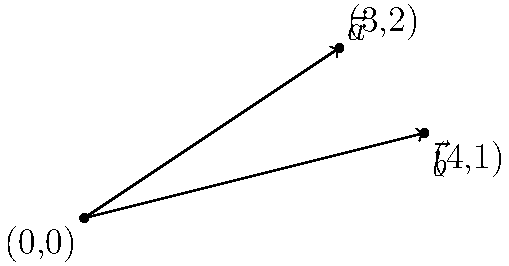Given two vectors $\vec{a} = (3,2)$ and $\vec{b} = (4,1)$ represented as arrows in a 2D plane, calculate their dot product. How would you approach this using your knowledge of vector operations and shell scripting? To calculate the dot product of two vectors $\vec{a} = (a_1, a_2)$ and $\vec{b} = (b_1, b_2)$ in a 2D plane, we use the formula:

$$\vec{a} \cdot \vec{b} = a_1b_1 + a_2b_2$$

For the given vectors $\vec{a} = (3,2)$ and $\vec{b} = (4,1)$:

1. Identify the components:
   $a_1 = 3$, $a_2 = 2$
   $b_1 = 4$, $b_2 = 1$

2. Multiply corresponding components:
   $a_1b_1 = 3 \times 4 = 12$
   $a_2b_2 = 2 \times 1 = 2$

3. Sum the products:
   $\vec{a} \cdot \vec{b} = 12 + 2 = 14$

Using shell scripting and bc (basic calculator) command, you could calculate this as:

```bash
#!/bin/bash
a1=3; a2=2
b1=4; b2=1
dot_product=$(echo "$a1 * $b1 + $a2 * $b2" | bc)
echo "The dot product is: $dot_product"
```

This script defines the vector components, calculates the dot product using bc, and outputs the result.
Answer: 14 